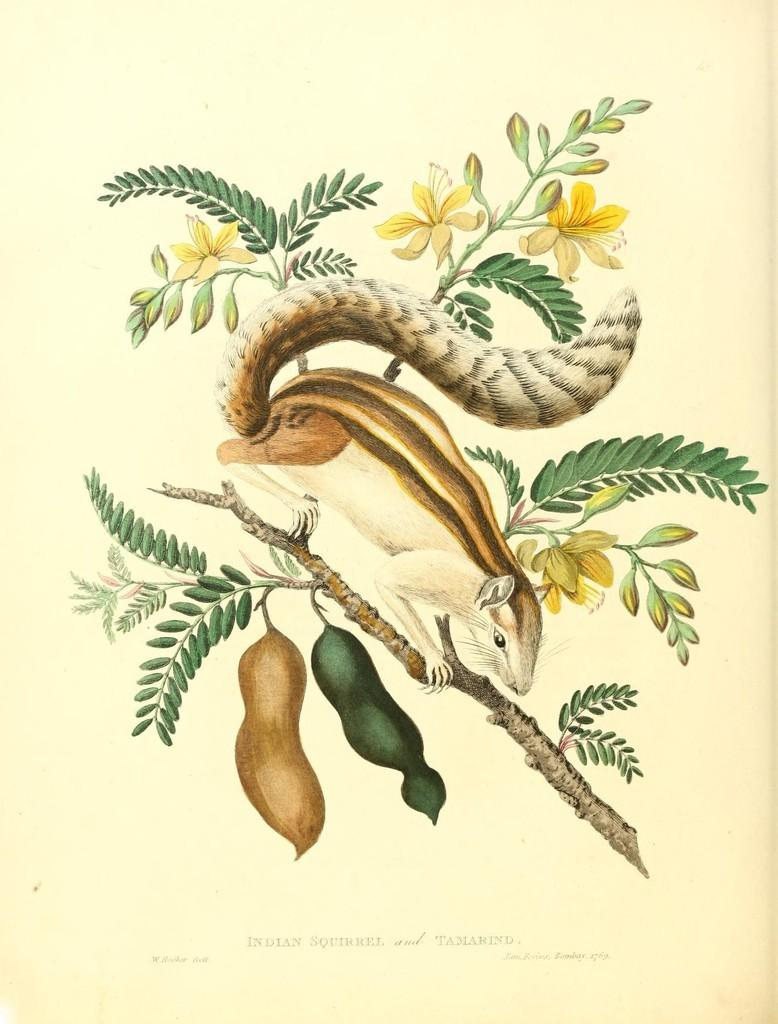What is depicted in the art in the image? There is an art of a squirrel in the image. Where is the squirrel located in the art? The squirrel is standing on a branch of a tree. What can be observed about the tree in the art? The tree has flowers and fruits. What is the condition of the squirrel's family in the image? There is no information about the squirrel's family in the image, as it only depicts a single squirrel on a tree branch. 